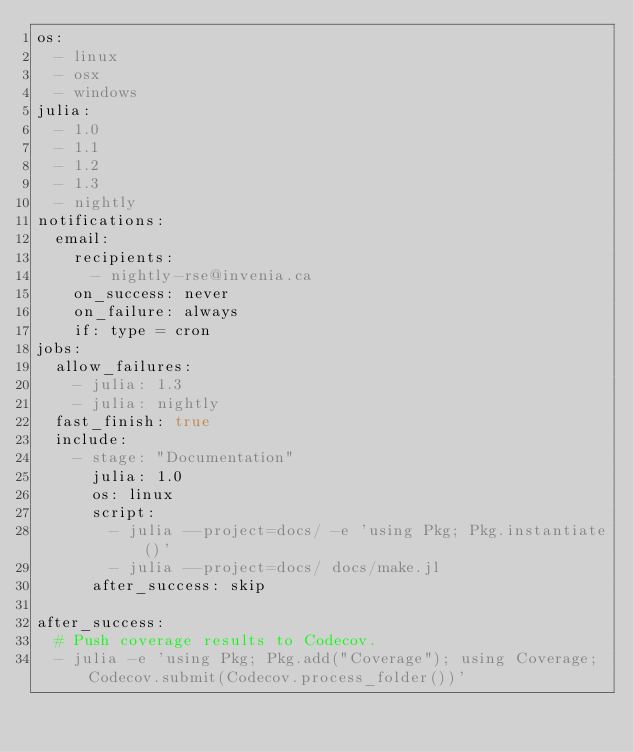Convert code to text. <code><loc_0><loc_0><loc_500><loc_500><_YAML_>os:
  - linux
  - osx
  - windows
julia:
  - 1.0
  - 1.1
  - 1.2
  - 1.3
  - nightly
notifications:
  email:
    recipients:
      - nightly-rse@invenia.ca
    on_success: never
    on_failure: always
    if: type = cron
jobs:
  allow_failures:
    - julia: 1.3
    - julia: nightly
  fast_finish: true
  include:
    - stage: "Documentation"
      julia: 1.0
      os: linux
      script:
        - julia --project=docs/ -e 'using Pkg; Pkg.instantiate()'
        - julia --project=docs/ docs/make.jl
      after_success: skip

after_success:
  # Push coverage results to Codecov.
  - julia -e 'using Pkg; Pkg.add("Coverage"); using Coverage; Codecov.submit(Codecov.process_folder())'
</code> 